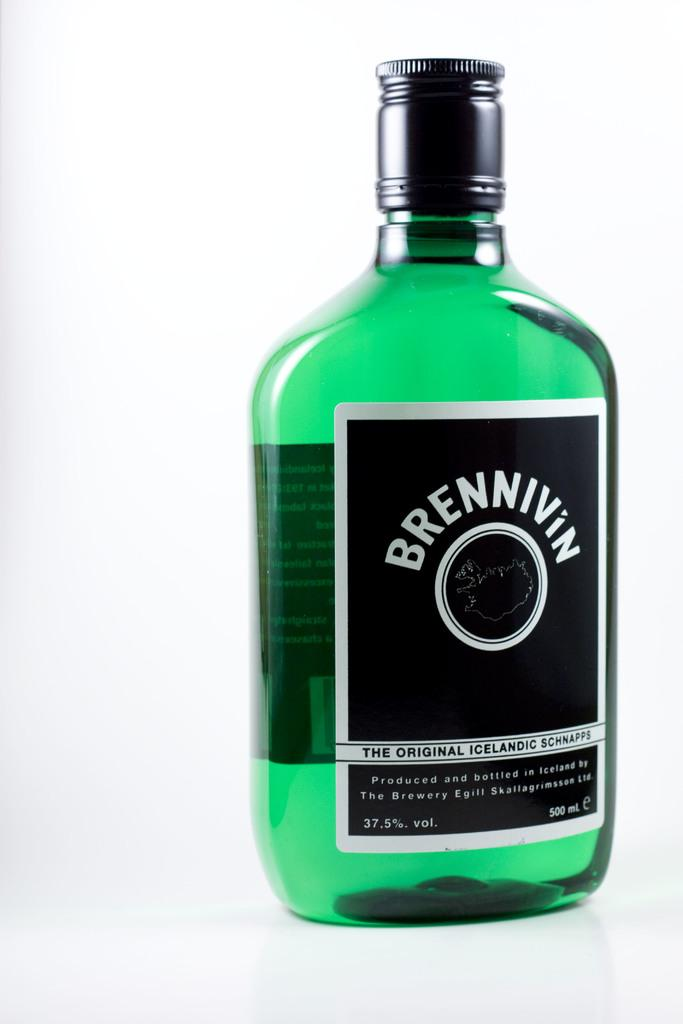Provide a one-sentence caption for the provided image. a bottle filled with green liquid called brennivin. 